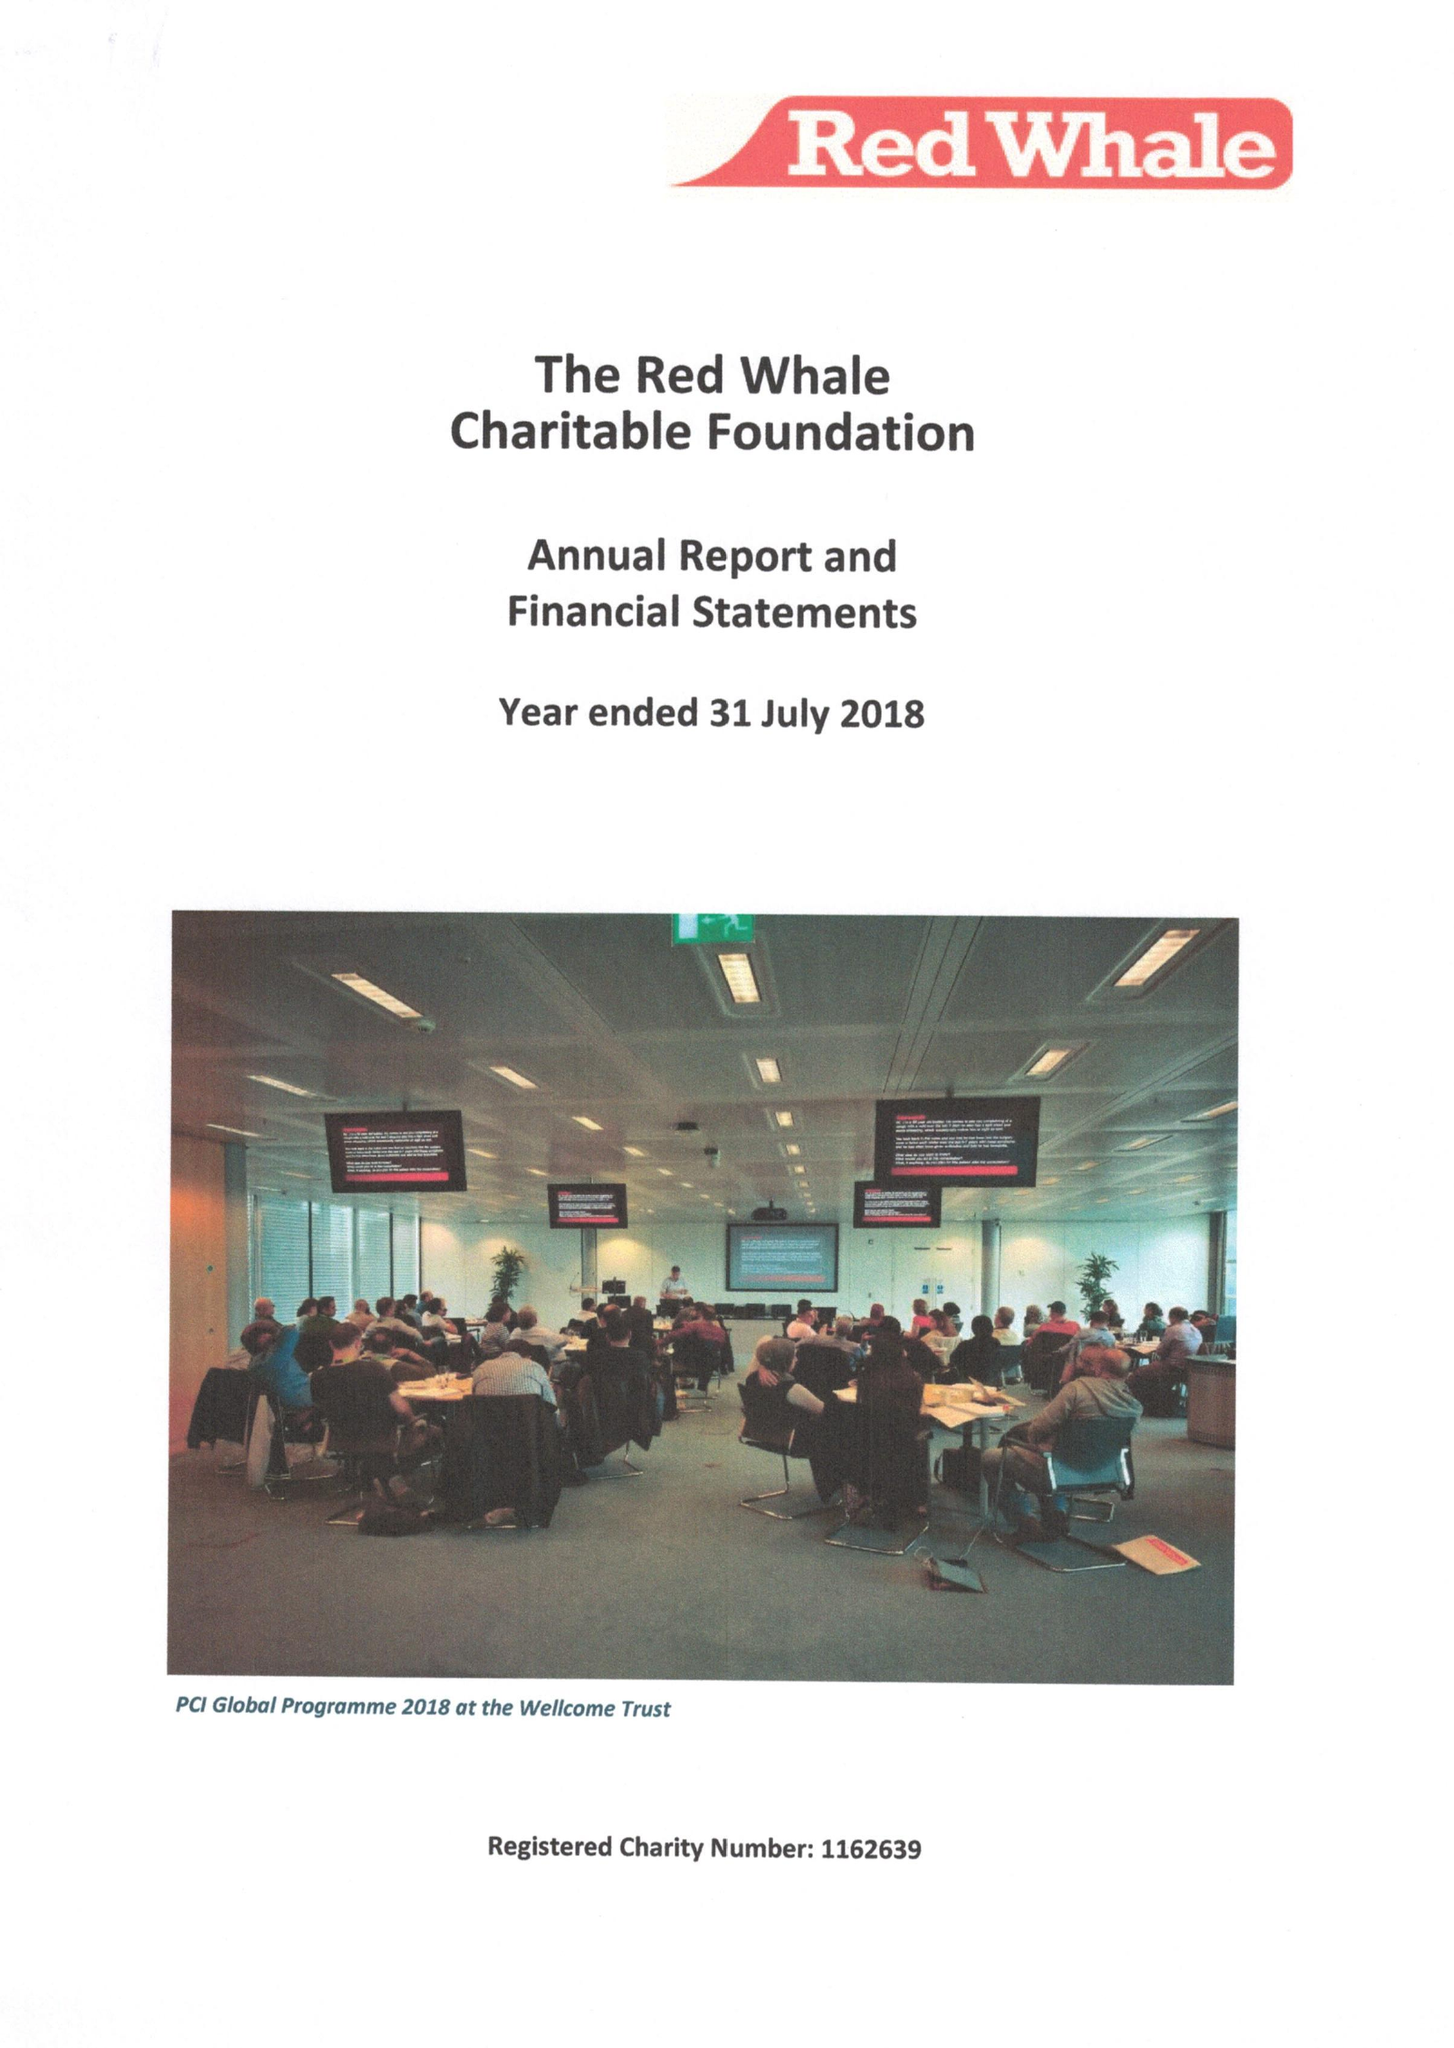What is the value for the income_annually_in_british_pounds?
Answer the question using a single word or phrase. 91128.00 